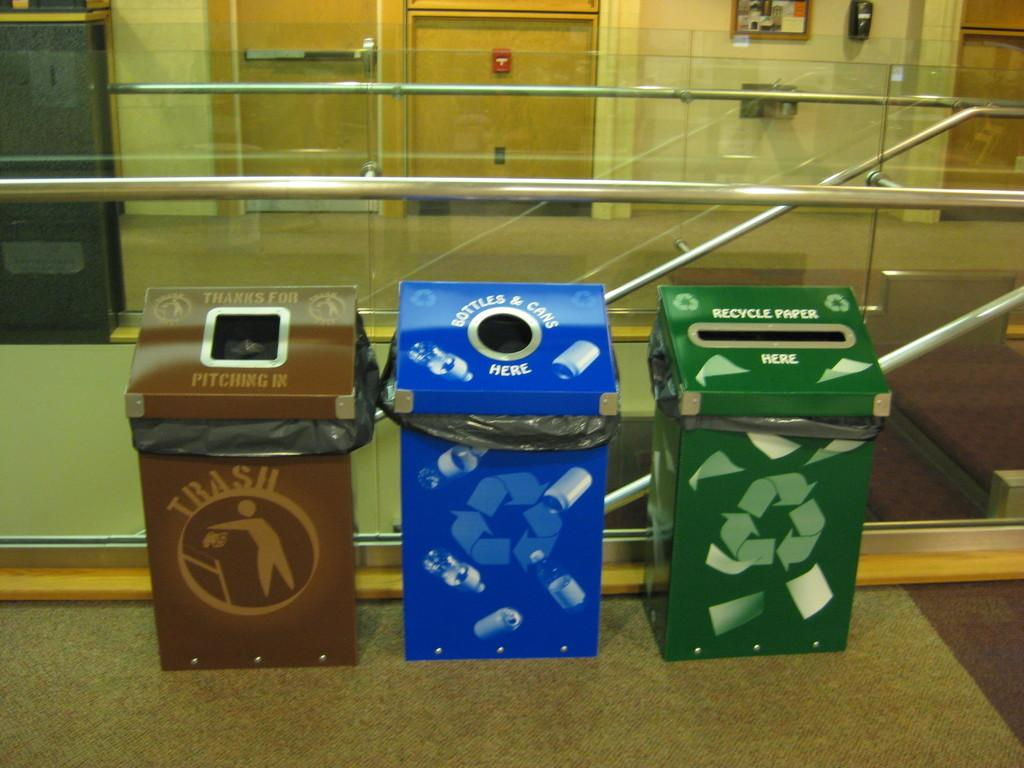<image>
Share a concise interpretation of the image provided. A brown trash bin, a blue bottles and cans recycling bin, and a green paper recycling bin in front of a glass and metal stair way. 